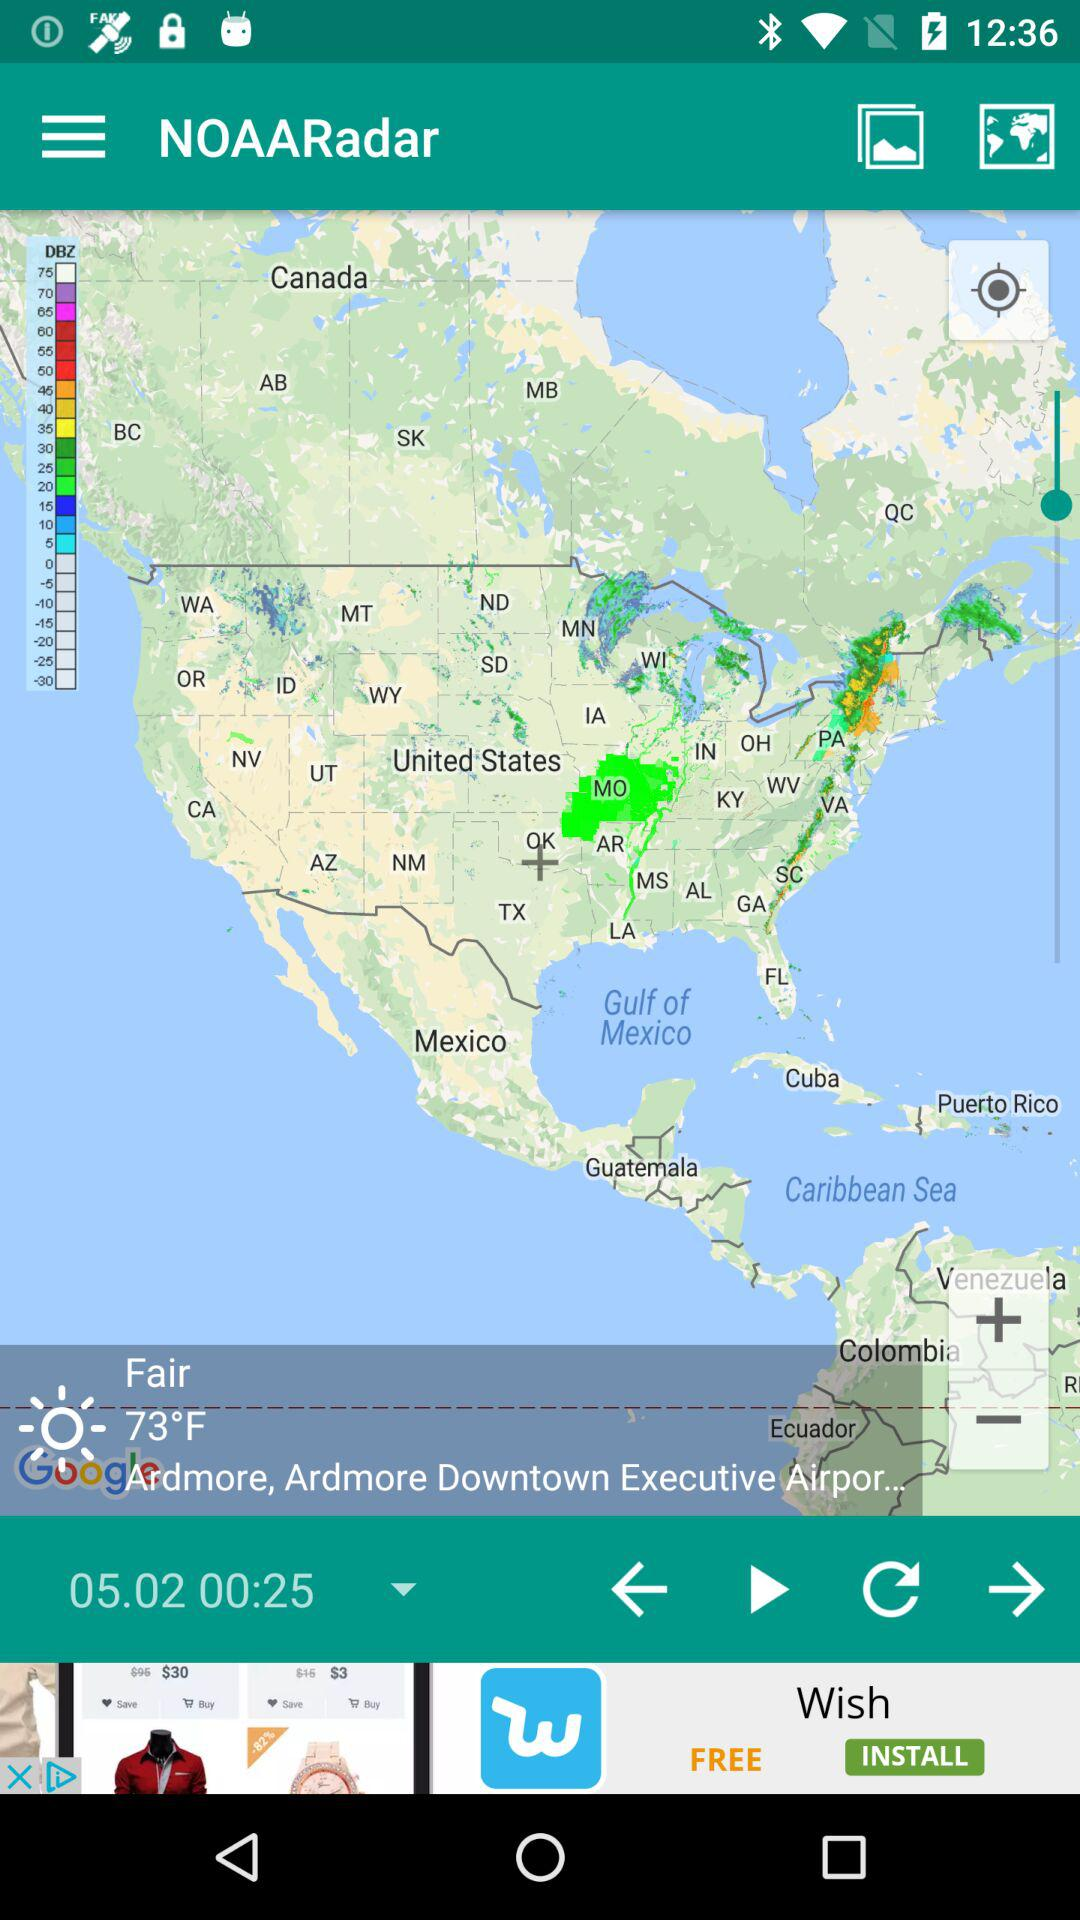What is the temperature? The temperature is 73° F. 